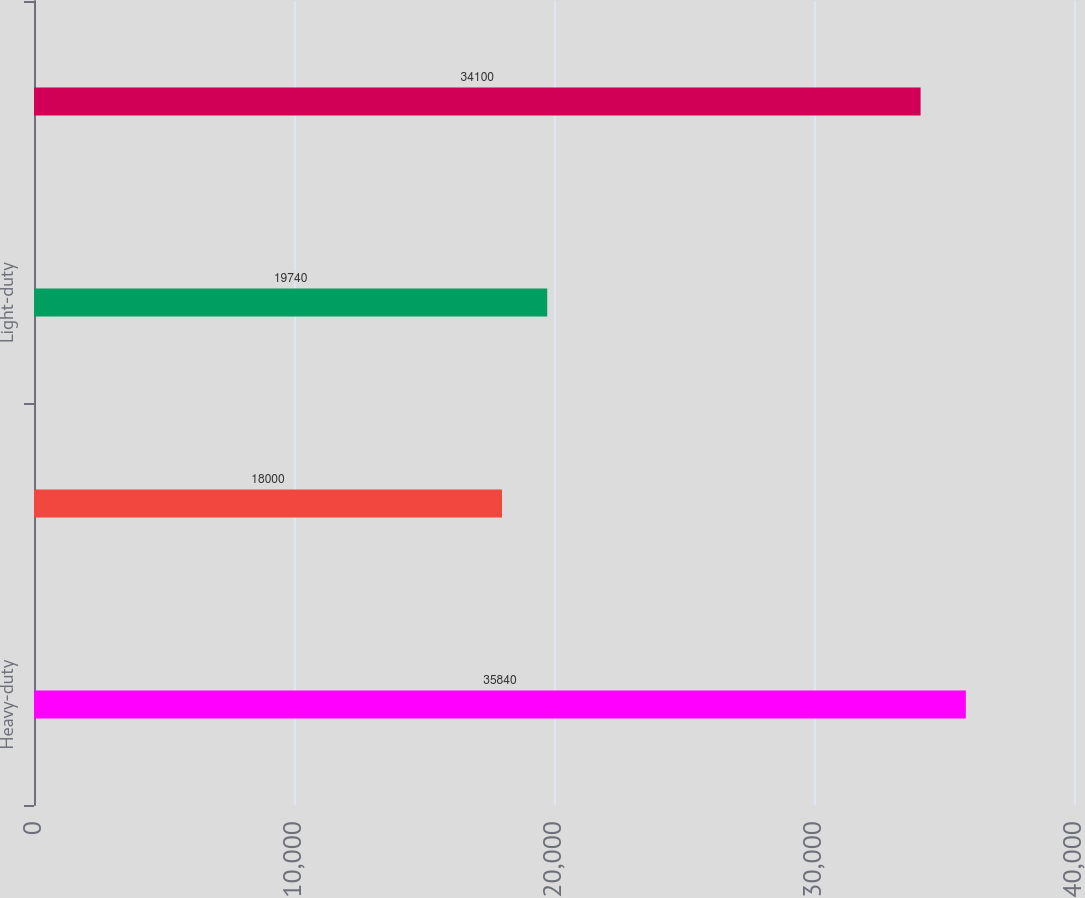Convert chart to OTSL. <chart><loc_0><loc_0><loc_500><loc_500><bar_chart><fcel>Heavy-duty<fcel>Medium-duty<fcel>Light-duty<fcel>Total unit shipments<nl><fcel>35840<fcel>18000<fcel>19740<fcel>34100<nl></chart> 